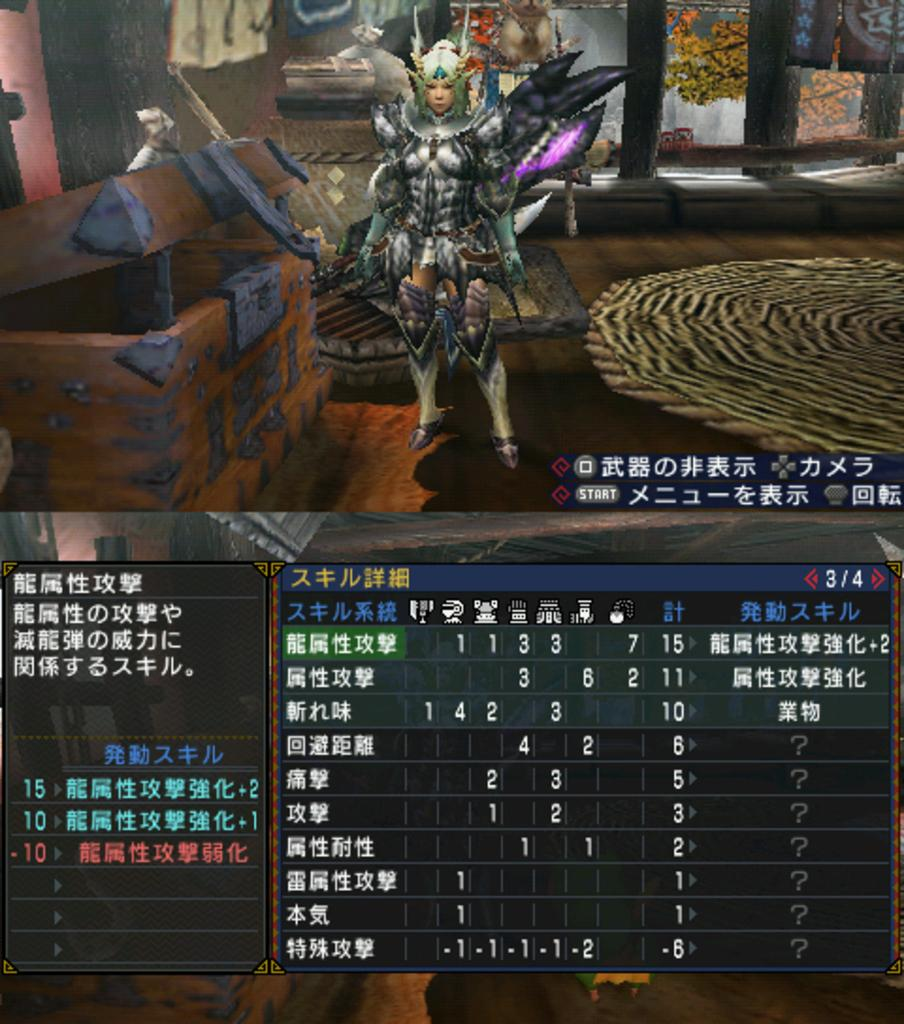Provide a one-sentence caption for the provided image. some Japanese writing that is on a screen. 